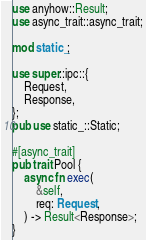Convert code to text. <code><loc_0><loc_0><loc_500><loc_500><_Rust_>use anyhow::Result;
use async_trait::async_trait;

mod static_;

use super::ipc::{
    Request,
    Response,
};
pub use static_::Static;

#[async_trait]
pub trait Pool {
    async fn exec(
        &self,
        req: Request,
    ) -> Result<Response>;
}
</code> 